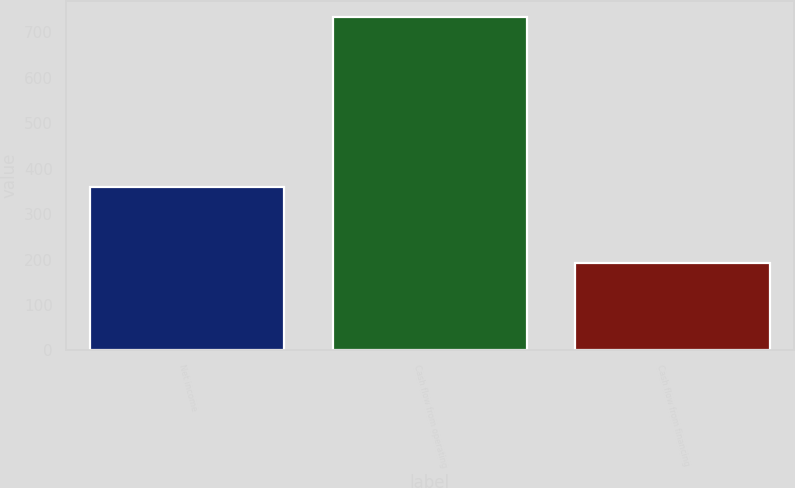Convert chart. <chart><loc_0><loc_0><loc_500><loc_500><bar_chart><fcel>Net income<fcel>Cash flow from operating<fcel>Cash flow from financing<nl><fcel>359<fcel>733<fcel>193<nl></chart> 